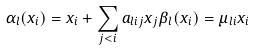Convert formula to latex. <formula><loc_0><loc_0><loc_500><loc_500>\alpha _ { l } ( x _ { i } ) = x _ { i } + \sum _ { j < i } a _ { l i j } x _ { j } \beta _ { l } ( x _ { i } ) = \mu _ { l i } x _ { i }</formula> 